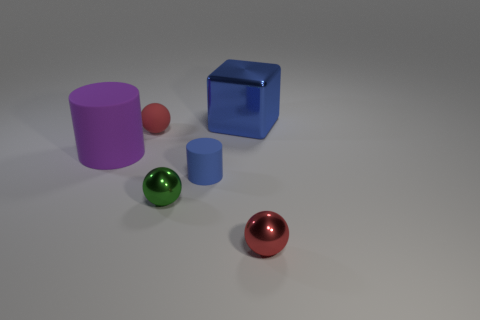Subtract all blocks. How many objects are left? 5 Add 2 blue cylinders. How many objects exist? 8 Add 6 blue metallic things. How many blue metallic things are left? 7 Add 3 big red metal balls. How many big red metal balls exist? 3 Subtract 0 gray cylinders. How many objects are left? 6 Subtract all big purple matte things. Subtract all red metal spheres. How many objects are left? 4 